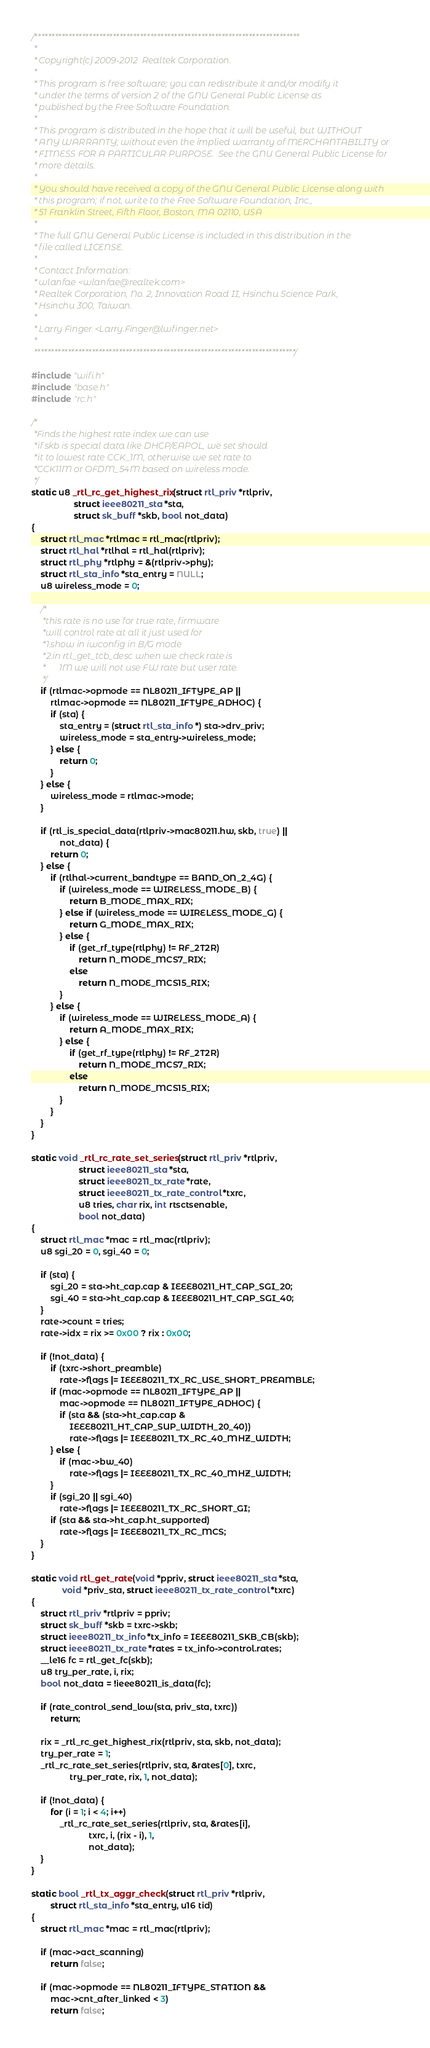Convert code to text. <code><loc_0><loc_0><loc_500><loc_500><_C_>/******************************************************************************
 *
 * Copyright(c) 2009-2012  Realtek Corporation.
 *
 * This program is free software; you can redistribute it and/or modify it
 * under the terms of version 2 of the GNU General Public License as
 * published by the Free Software Foundation.
 *
 * This program is distributed in the hope that it will be useful, but WITHOUT
 * ANY WARRANTY; without even the implied warranty of MERCHANTABILITY or
 * FITNESS FOR A PARTICULAR PURPOSE.  See the GNU General Public License for
 * more details.
 *
 * You should have received a copy of the GNU General Public License along with
 * this program; if not, write to the Free Software Foundation, Inc.,
 * 51 Franklin Street, Fifth Floor, Boston, MA 02110, USA
 *
 * The full GNU General Public License is included in this distribution in the
 * file called LICENSE.
 *
 * Contact Information:
 * wlanfae <wlanfae@realtek.com>
 * Realtek Corporation, No. 2, Innovation Road II, Hsinchu Science Park,
 * Hsinchu 300, Taiwan.
 *
 * Larry Finger <Larry.Finger@lwfinger.net>
 *
 *****************************************************************************/

#include "wifi.h"
#include "base.h"
#include "rc.h"

/*
 *Finds the highest rate index we can use
 *if skb is special data like DHCP/EAPOL, we set should
 *it to lowest rate CCK_1M, otherwise we set rate to
 *CCK11M or OFDM_54M based on wireless mode.
 */
static u8 _rtl_rc_get_highest_rix(struct rtl_priv *rtlpriv,
				  struct ieee80211_sta *sta,
				  struct sk_buff *skb, bool not_data)
{
	struct rtl_mac *rtlmac = rtl_mac(rtlpriv);
	struct rtl_hal *rtlhal = rtl_hal(rtlpriv);
	struct rtl_phy *rtlphy = &(rtlpriv->phy);
	struct rtl_sta_info *sta_entry = NULL;
	u8 wireless_mode = 0;

	/*
	 *this rate is no use for true rate, firmware
	 *will control rate at all it just used for
	 *1.show in iwconfig in B/G mode
	 *2.in rtl_get_tcb_desc when we check rate is
	 *      1M we will not use FW rate but user rate.
	 */
	if (rtlmac->opmode == NL80211_IFTYPE_AP ||
		rtlmac->opmode == NL80211_IFTYPE_ADHOC) {
		if (sta) {
			sta_entry = (struct rtl_sta_info *) sta->drv_priv;
			wireless_mode = sta_entry->wireless_mode;
		} else {
			return 0;
		}
	} else {
		wireless_mode = rtlmac->mode;
	}

	if (rtl_is_special_data(rtlpriv->mac80211.hw, skb, true) ||
			not_data) {
		return 0;
	} else {
		if (rtlhal->current_bandtype == BAND_ON_2_4G) {
			if (wireless_mode == WIRELESS_MODE_B) {
				return B_MODE_MAX_RIX;
			} else if (wireless_mode == WIRELESS_MODE_G) {
				return G_MODE_MAX_RIX;
			} else {
				if (get_rf_type(rtlphy) != RF_2T2R)
					return N_MODE_MCS7_RIX;
				else
					return N_MODE_MCS15_RIX;
			}
		} else {
			if (wireless_mode == WIRELESS_MODE_A) {
				return A_MODE_MAX_RIX;
			} else {
				if (get_rf_type(rtlphy) != RF_2T2R)
					return N_MODE_MCS7_RIX;
				else
					return N_MODE_MCS15_RIX;
			}
		}
	}
}

static void _rtl_rc_rate_set_series(struct rtl_priv *rtlpriv,
				    struct ieee80211_sta *sta,
				    struct ieee80211_tx_rate *rate,
				    struct ieee80211_tx_rate_control *txrc,
				    u8 tries, char rix, int rtsctsenable,
				    bool not_data)
{
	struct rtl_mac *mac = rtl_mac(rtlpriv);
	u8 sgi_20 = 0, sgi_40 = 0;

	if (sta) {
		sgi_20 = sta->ht_cap.cap & IEEE80211_HT_CAP_SGI_20;
		sgi_40 = sta->ht_cap.cap & IEEE80211_HT_CAP_SGI_40;
	}
	rate->count = tries;
	rate->idx = rix >= 0x00 ? rix : 0x00;

	if (!not_data) {
		if (txrc->short_preamble)
			rate->flags |= IEEE80211_TX_RC_USE_SHORT_PREAMBLE;
		if (mac->opmode == NL80211_IFTYPE_AP ||
			mac->opmode == NL80211_IFTYPE_ADHOC) {
			if (sta && (sta->ht_cap.cap &
			    IEEE80211_HT_CAP_SUP_WIDTH_20_40))
				rate->flags |= IEEE80211_TX_RC_40_MHZ_WIDTH;
		} else {
			if (mac->bw_40)
				rate->flags |= IEEE80211_TX_RC_40_MHZ_WIDTH;
		}
		if (sgi_20 || sgi_40)
			rate->flags |= IEEE80211_TX_RC_SHORT_GI;
		if (sta && sta->ht_cap.ht_supported)
			rate->flags |= IEEE80211_TX_RC_MCS;
	}
}

static void rtl_get_rate(void *ppriv, struct ieee80211_sta *sta,
			 void *priv_sta, struct ieee80211_tx_rate_control *txrc)
{
	struct rtl_priv *rtlpriv = ppriv;
	struct sk_buff *skb = txrc->skb;
	struct ieee80211_tx_info *tx_info = IEEE80211_SKB_CB(skb);
	struct ieee80211_tx_rate *rates = tx_info->control.rates;
	__le16 fc = rtl_get_fc(skb);
	u8 try_per_rate, i, rix;
	bool not_data = !ieee80211_is_data(fc);

	if (rate_control_send_low(sta, priv_sta, txrc))
		return;

	rix = _rtl_rc_get_highest_rix(rtlpriv, sta, skb, not_data);
	try_per_rate = 1;
	_rtl_rc_rate_set_series(rtlpriv, sta, &rates[0], txrc,
				try_per_rate, rix, 1, not_data);

	if (!not_data) {
		for (i = 1; i < 4; i++)
			_rtl_rc_rate_set_series(rtlpriv, sta, &rates[i],
						txrc, i, (rix - i), 1,
						not_data);
	}
}

static bool _rtl_tx_aggr_check(struct rtl_priv *rtlpriv,
		struct rtl_sta_info *sta_entry, u16 tid)
{
	struct rtl_mac *mac = rtl_mac(rtlpriv);

	if (mac->act_scanning)
		return false;

	if (mac->opmode == NL80211_IFTYPE_STATION &&
		mac->cnt_after_linked < 3)
		return false;
</code> 